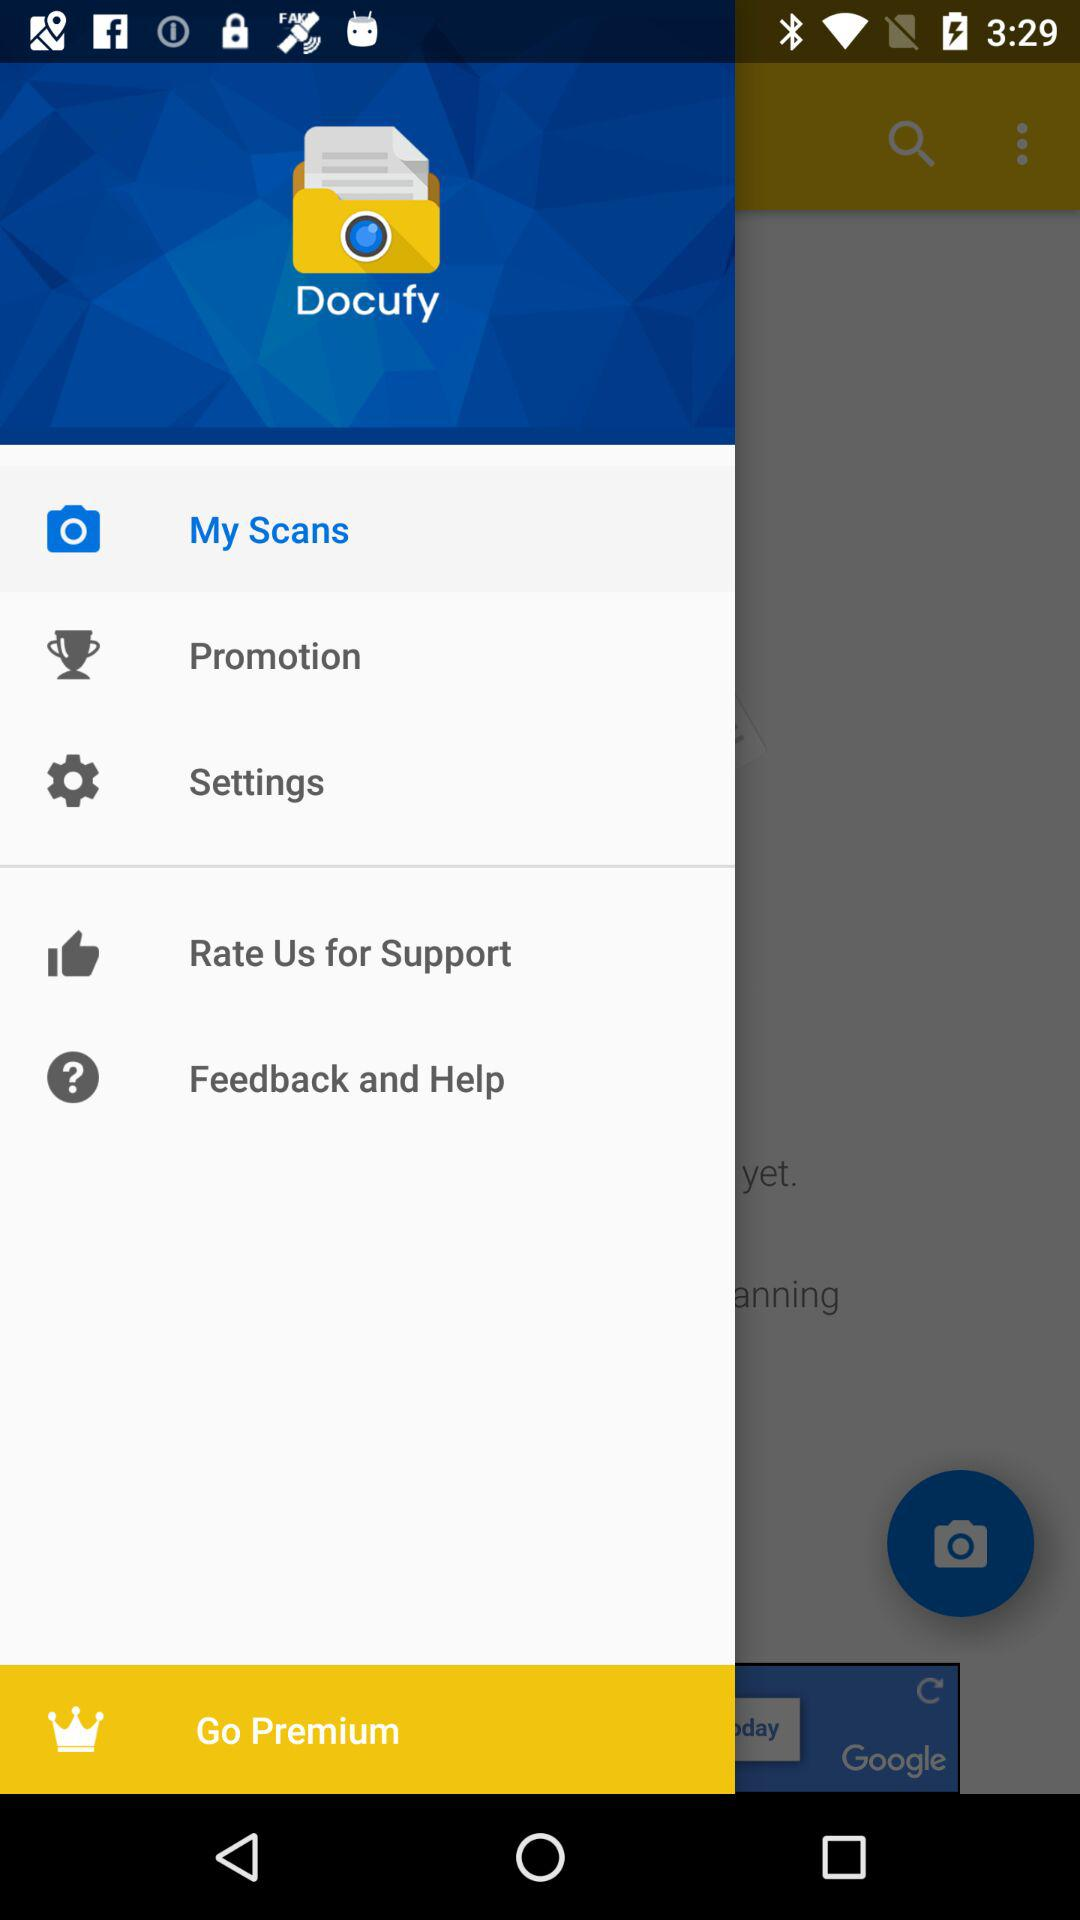What is the application name? The application name is "Docufy". 